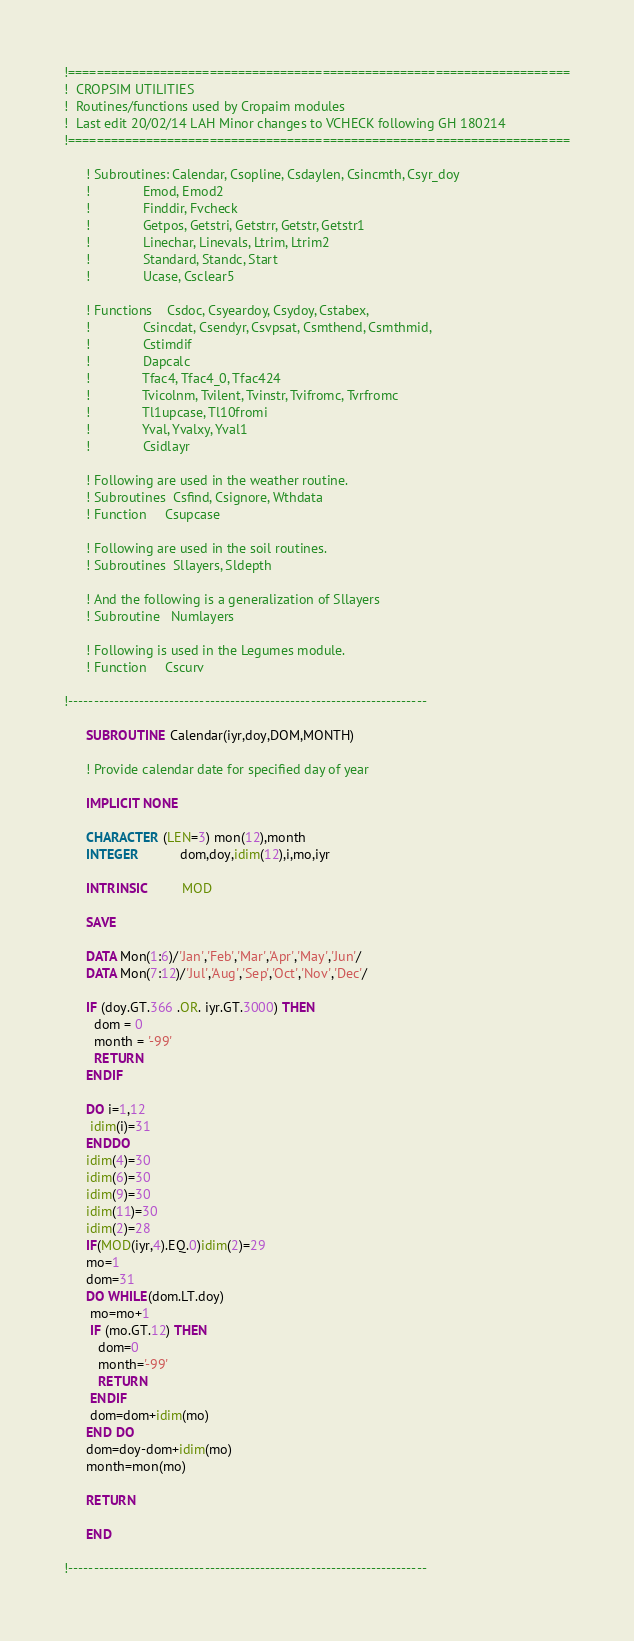<code> <loc_0><loc_0><loc_500><loc_500><_FORTRAN_>!=======================================================================
!  CROPSIM UTILITIES    
!  Routines/functions used by Cropaim modules
!  Last edit 20/02/14 LAH Minor changes to VCHECK following GH 180214
!=======================================================================

      ! Subroutines: Calendar, Csopline, Csdaylen, Csincmth, Csyr_doy
      !              Emod, Emod2
      !              Finddir, Fvcheck
      !              Getpos, Getstri, Getstrr, Getstr, Getstr1
      !              Linechar, Linevals, Ltrim, Ltrim2
      !              Standard, Standc, Start
      !              Ucase, Csclear5

      ! Functions    Csdoc, Csyeardoy, Csydoy, Cstabex,
      !              Csincdat, Csendyr, Csvpsat, Csmthend, Csmthmid,
      !              Cstimdif
      !              Dapcalc
      !              Tfac4, Tfac4_0, Tfac424
      !              Tvicolnm, Tvilent, Tvinstr, Tvifromc, Tvrfromc
      !              Tl1upcase, Tl10fromi
      !              Yval, Yvalxy, Yval1
      !              Csidlayr

      ! Following are used in the weather routine.
      ! Subroutines  Csfind, Csignore, Wthdata
      ! Function     Csupcase

      ! Following are used in the soil routines.
      ! Subroutines  Sllayers, Sldepth

      ! And the following is a generalization of Sllayers
      ! Subroutine   Numlayers

      ! Following is used in the Legumes module.
      ! Function     Cscurv

!-----------------------------------------------------------------------

      SUBROUTINE Calendar(iyr,doy,DOM,MONTH)

      ! Provide calendar date for specified day of year

      IMPLICIT NONE

      CHARACTER (LEN=3) mon(12),month
      INTEGER           dom,doy,idim(12),i,mo,iyr

      INTRINSIC         MOD

      SAVE

      DATA Mon(1:6)/'Jan','Feb','Mar','Apr','May','Jun'/
      DATA Mon(7:12)/'Jul','Aug','Sep','Oct','Nov','Dec'/

      IF (doy.GT.366 .OR. iyr.GT.3000) THEN
        dom = 0
        month = '-99'
        RETURN
      ENDIF

      DO i=1,12
       idim(i)=31
      ENDDO
      idim(4)=30
      idim(6)=30
      idim(9)=30
      idim(11)=30
      idim(2)=28
      IF(MOD(iyr,4).EQ.0)idim(2)=29
      mo=1
      dom=31
      DO WHILE(dom.LT.doy)
       mo=mo+1
       IF (mo.GT.12) THEN
         dom=0
         month='-99'
         RETURN
       ENDIF
       dom=dom+idim(mo)
      END DO
      dom=doy-dom+idim(mo)
      month=mon(mo)

      RETURN

      END

!-----------------------------------------------------------------------
</code> 